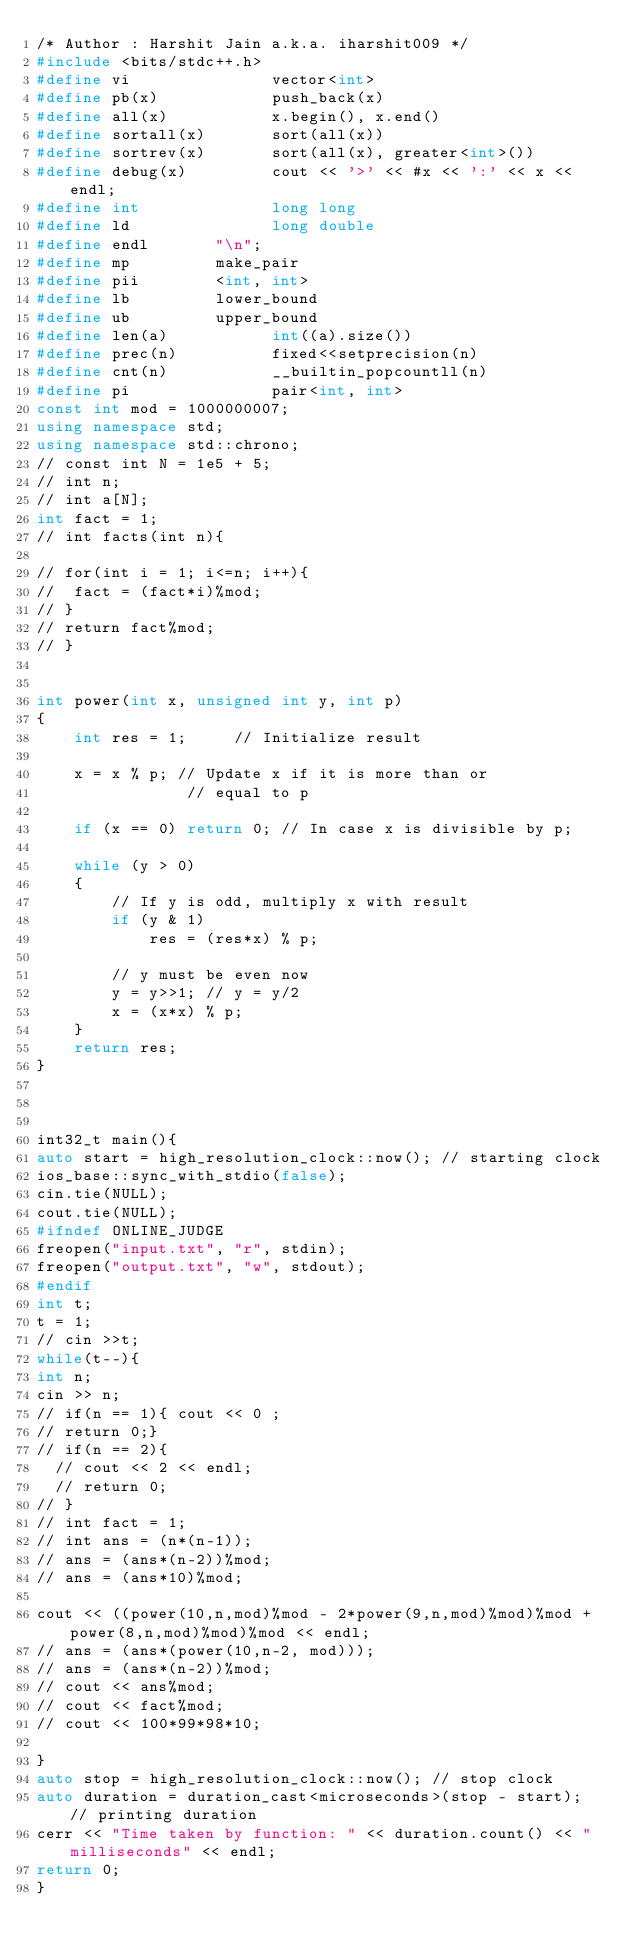Convert code to text. <code><loc_0><loc_0><loc_500><loc_500><_C++_>/* Author : Harshit Jain a.k.a. iharshit009 */
#include <bits/stdc++.h>
#define vi               vector<int>
#define pb(x)            push_back(x)
#define all(x)           x.begin(), x.end()
#define sortall(x)       sort(all(x))
#define sortrev(x)       sort(all(x), greater<int>())
#define debug(x)         cout << '>' << #x << ':' << x << endl;
#define int              long long
#define ld               long double
#define endl 			 "\n";
#define mp 				 make_pair
#define pii 			 <int, int>
#define lb 				 lower_bound
#define ub				 upper_bound
#define len(a)           int((a).size())
#define prec(n)          fixed<<setprecision(n)
#define cnt(n)           __builtin_popcountll(n)
#define pi               pair<int, int>
const int mod = 1000000007;
using namespace std;
using namespace std::chrono;
// const int N = 1e5 + 5; 
// int n;
// int a[N];
int fact = 1;
// int facts(int n){

// for(int i = 1; i<=n; i++){
// 	fact = (fact*i)%mod;
// }
// return fact%mod;
// }


int power(int x, unsigned int y, int p)  
{  
    int res = 1;     // Initialize result  
  
    x = x % p; // Update x if it is more than or  
                // equal to p 
   
    if (x == 0) return 0; // In case x is divisible by p; 
  
    while (y > 0)  
    {  
        // If y is odd, multiply x with result  
        if (y & 1)  
            res = (res*x) % p;  
  
        // y must be even now  
        y = y>>1; // y = y/2  
        x = (x*x) % p;  
    }  
    return res;  
}  



int32_t main(){
auto start = high_resolution_clock::now(); // starting clock
ios_base::sync_with_stdio(false);
cin.tie(NULL);
cout.tie(NULL);
#ifndef ONLINE_JUDGE
freopen("input.txt", "r", stdin);
freopen("output.txt", "w", stdout);
#endif
int t;
t = 1;
// cin >>t;
while(t--){
int n;
cin >> n;
// if(n == 1){ cout << 0 ;
// return 0;}
// if(n == 2){
	// cout << 2 << endl;
	// return 0;
// }
// int fact = 1;
// int ans = (n*(n-1));
// ans = (ans*(n-2))%mod;
// ans = (ans*10)%mod;

cout << ((power(10,n,mod)%mod - 2*power(9,n,mod)%mod)%mod + power(8,n,mod)%mod)%mod << endl;
// ans = (ans*(power(10,n-2, mod)));
// ans = (ans*(n-2))%mod;
// cout << ans%mod;
// cout << fact%mod;
// cout << 100*99*98*10;

}
auto stop = high_resolution_clock::now(); // stop clock
auto duration = duration_cast<microseconds>(stop - start);  // printing duration
cerr << "Time taken by function: " << duration.count() << " milliseconds" << endl; 
return 0;
}</code> 